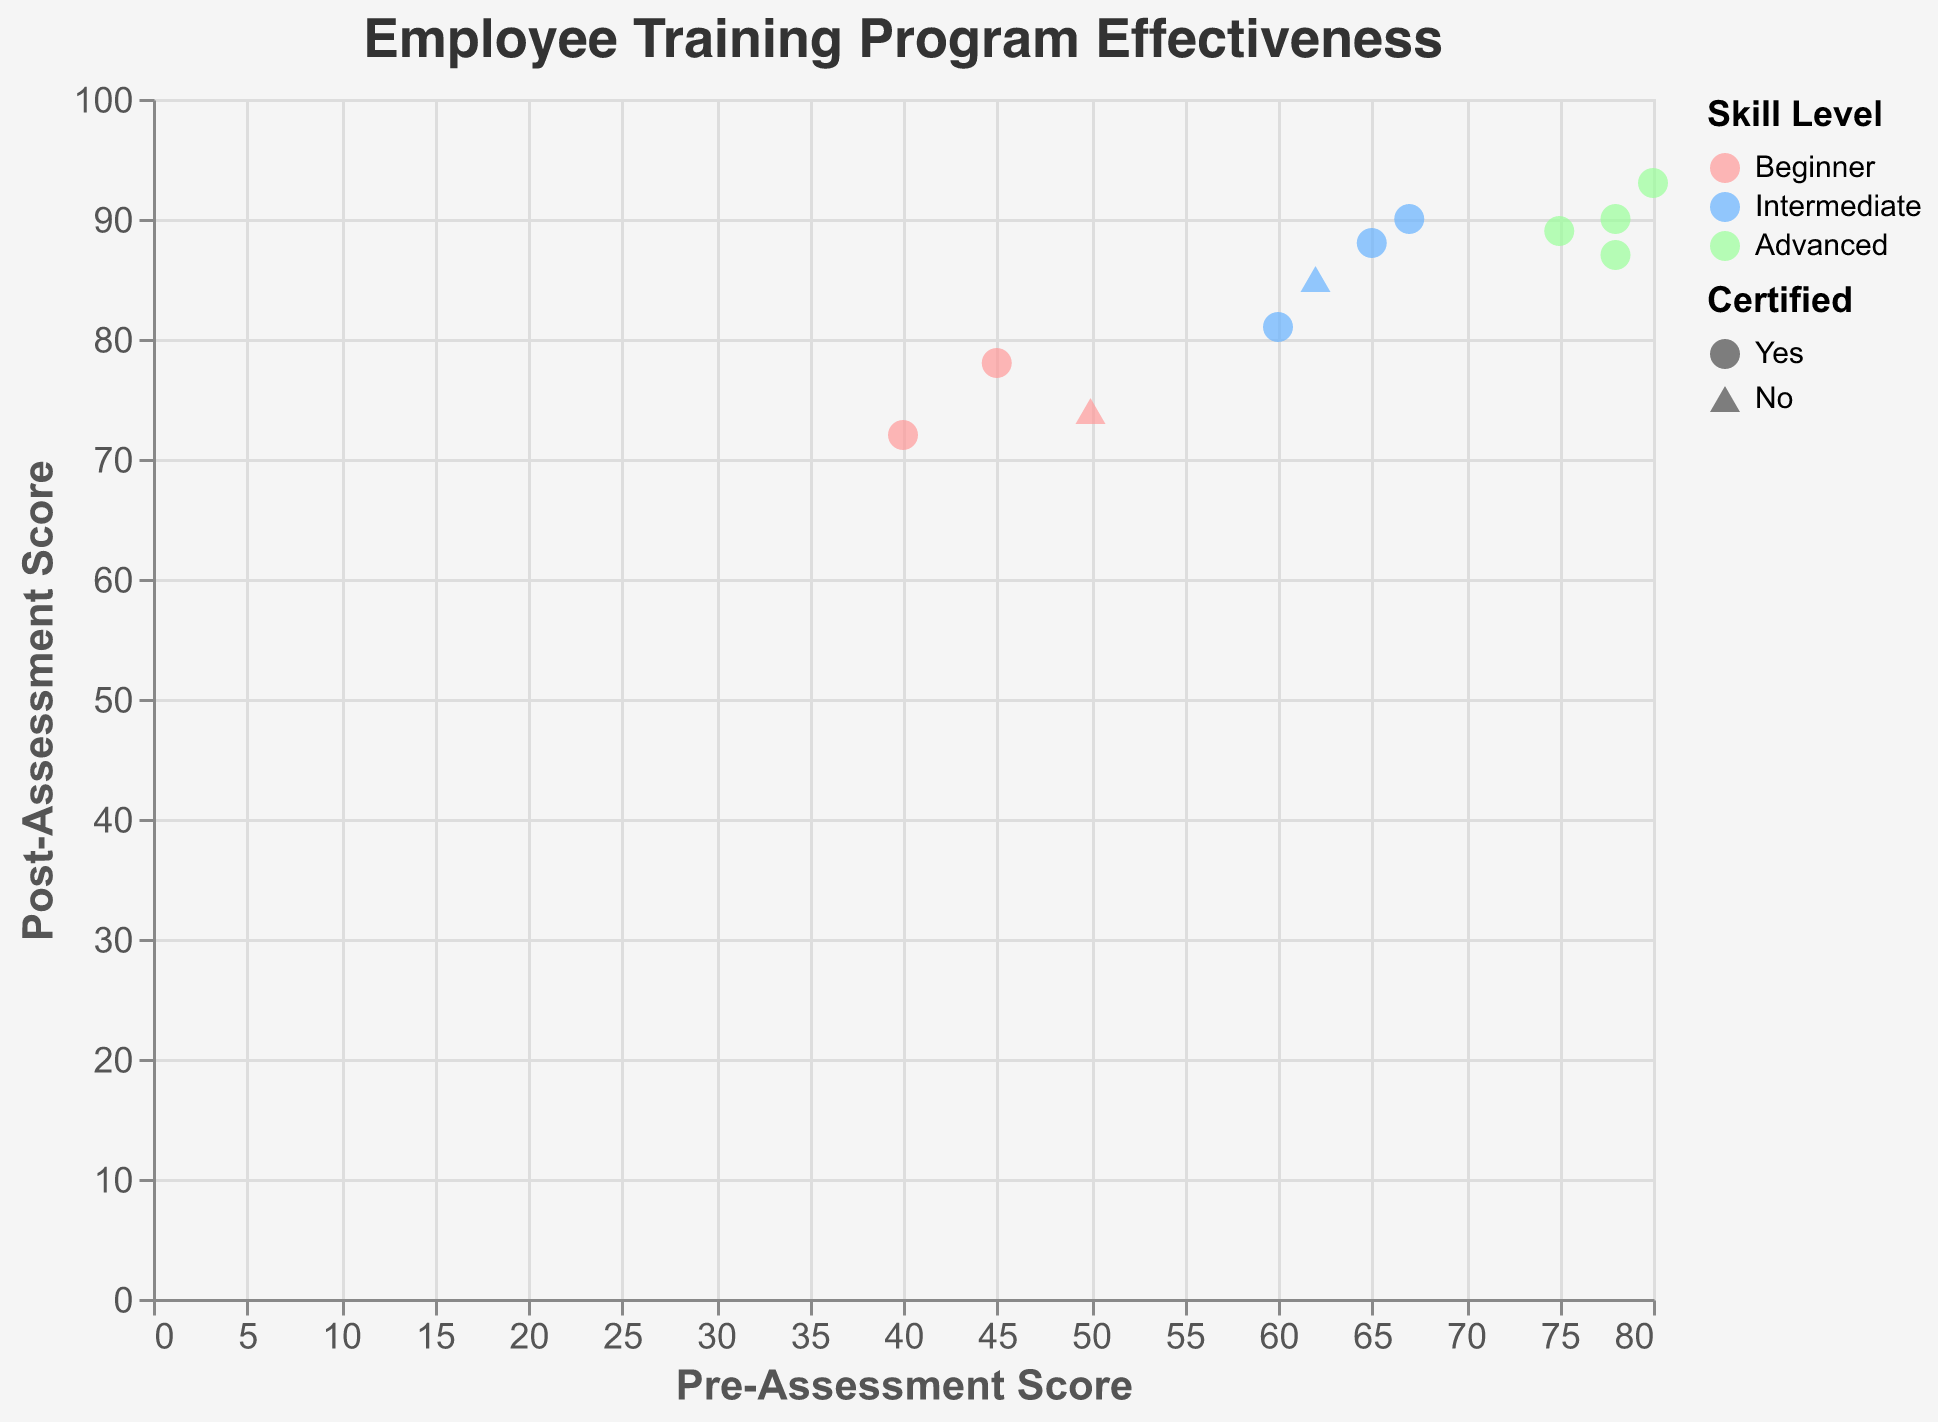What is the title of the plot? The title of the plot is displayed at the top center, usually in a larger font size than other text elements. It summarizes the overall content of the plot.
Answer: Employee Training Program Effectiveness How many employees are classified as 'Advanced' skill level? Look for data points that are color-coded with the color associated with 'Advanced'. Count these points.
Answer: 5 Which training program has the highest post-assessment score? Identify the data point with the highest y-axis value (Post-Assessment Score), then check the corresponding tooltip to find the Training Program Name.
Answer: Advanced Data Analysis Which employees did not get certified after training? Identify the data points with the triangle-up shape, which represents 'No' certification. Check their tooltip to find the Employee Names.
Answer: Jane Doe, Lucy Brown What is the average post-assessment score for beginner skill level? Find all data points colored with the 'Beginner' color. Sum their y-axis (Post-Assessment Score) values and divide by the number of points.
Answer: 74.67 What is the average difference between pre- and post-assessment scores for intermediate skill level? For all 'Intermediate' skill level points, calculate the difference between each Post-Assessment Score and Pre-Assessment Score, sum these differences, and divide by the number of points.
Answer: 23 Which skill level has the widest range of post-assessment scores? Compare the range (difference between maximum and minimum) of y-axis values (Post-Assessment Scores) within each color-coded skill level group.
Answer: Intermediate Do 'Certified' employees generally have higher post-assessment scores than 'Not Certified' employees? Compare the y-axis (Post-Assessment Score) values of circle points (Certified) and triangle-up points (Not Certified).
Answer: Yes How does the pre-assessment score relate to the post-assessment score? Examine the overall trend of the data points. If points with higher x-axis (Pre-Assessment Score) values generally have higher y-axis (Post-Assessment Score) values, there's a positive relationship.
Answer: Positive relationship Which 'Beginner' level employee showed the most improvement in their assessment scores? Find all 'Beginner' colored points. Calculate the difference between their Post-Assessment Score and Pre-Assessment Score, then identify the maximum difference.
Answer: John Smith 